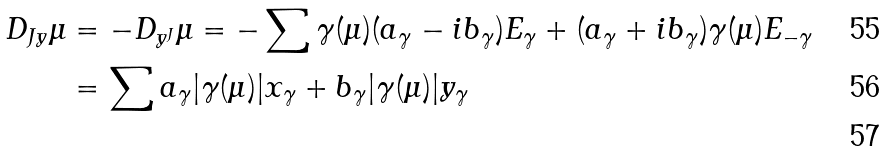Convert formula to latex. <formula><loc_0><loc_0><loc_500><loc_500>D _ { J y } \mu & = - D _ { y ^ { J } } \mu = - \sum \gamma ( \mu ) ( a _ { \gamma } - i b _ { \gamma } ) E _ { \gamma } + ( a _ { \gamma } + i b _ { \gamma } ) \gamma ( \mu ) E _ { - \gamma } \\ & = \sum a _ { \gamma } | \gamma ( \mu ) | x _ { \gamma } + b _ { \gamma } | \gamma ( \mu ) | y _ { \gamma } \\</formula> 